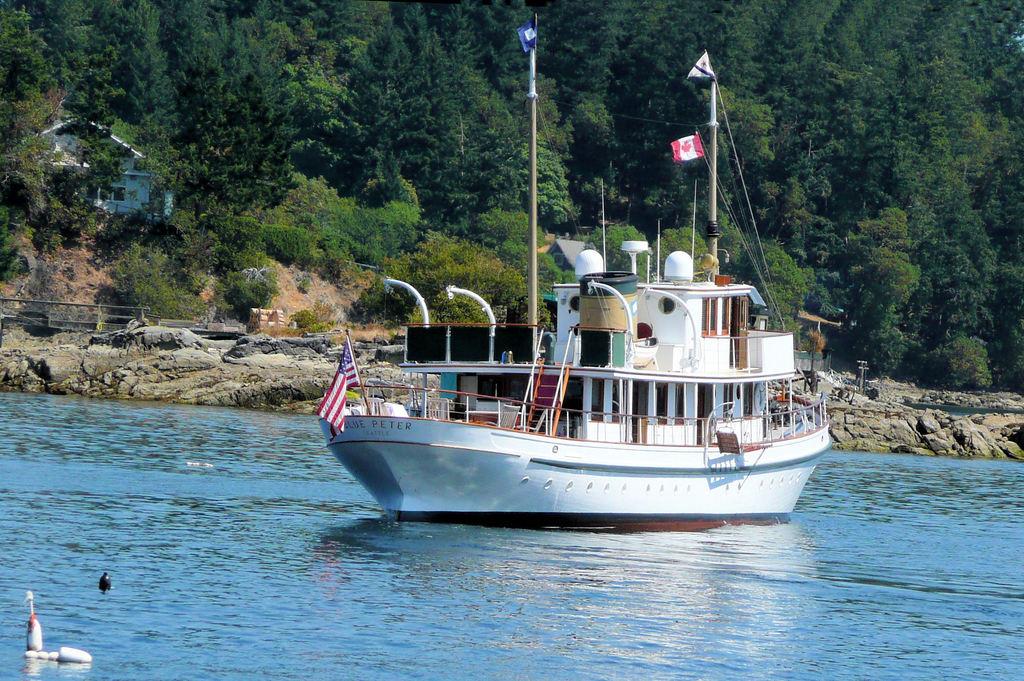What is the name of the boat?
Make the answer very short. Blue peter. What city is this boat from?
Ensure brevity in your answer.  Seattle. 